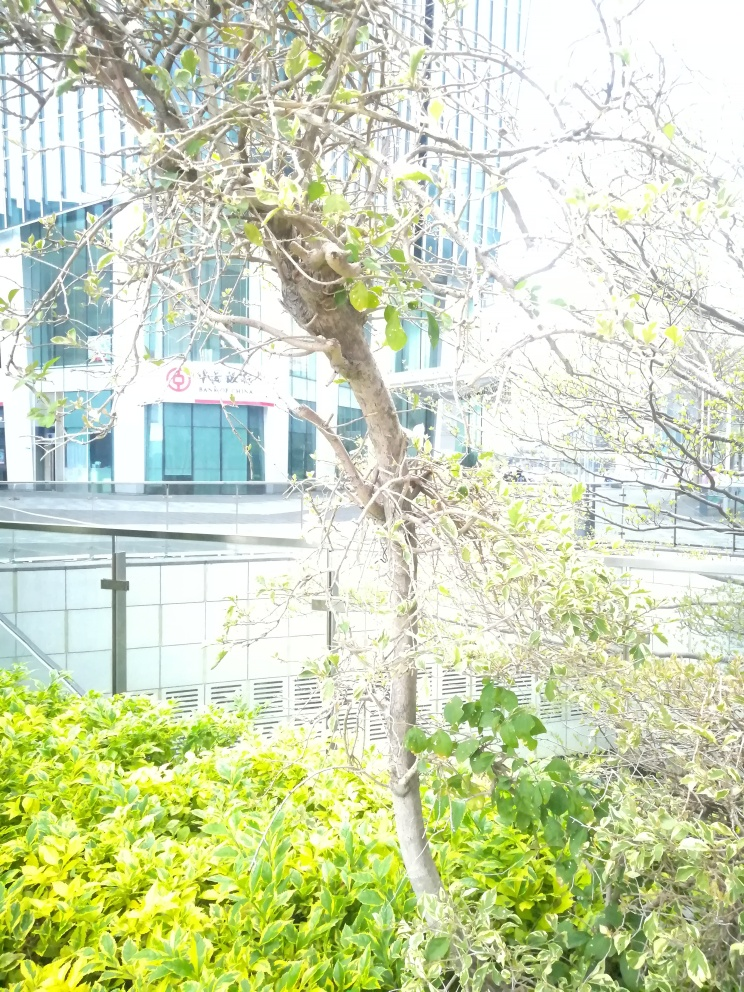Is this area likely to be a public space or private property based on visual cues? Given the open layout, the presence of the tree, and the well-maintained shrubbery, this area could likely be a public space designed for the enjoyment of the community. The structured design further indicates it could be part of a commercial zone meant for public access. 